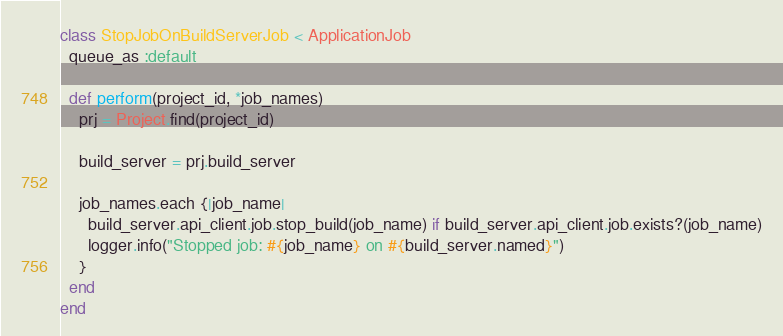<code> <loc_0><loc_0><loc_500><loc_500><_Ruby_>class StopJobOnBuildServerJob < ApplicationJob
  queue_as :default

  def perform(project_id, *job_names)
    prj = Project.find(project_id)

    build_server = prj.build_server

    job_names.each {|job_name|
      build_server.api_client.job.stop_build(job_name) if build_server.api_client.job.exists?(job_name)
      logger.info("Stopped job: #{job_name} on #{build_server.named}")
    }
  end
end
</code> 